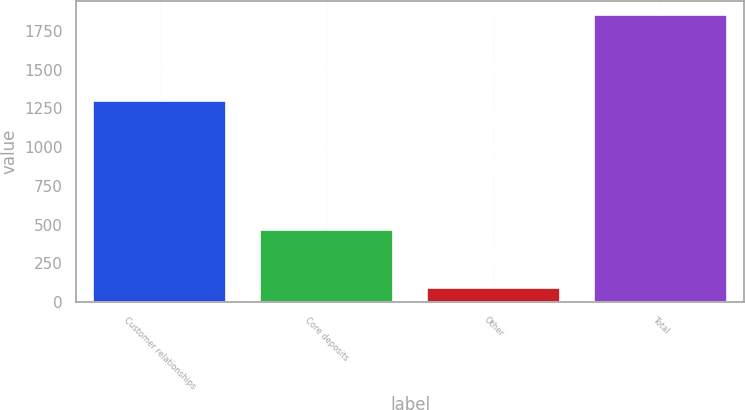Convert chart to OTSL. <chart><loc_0><loc_0><loc_500><loc_500><bar_chart><fcel>Customer relationships<fcel>Core deposits<fcel>Other<fcel>Total<nl><fcel>1296<fcel>466<fcel>89<fcel>1851<nl></chart> 